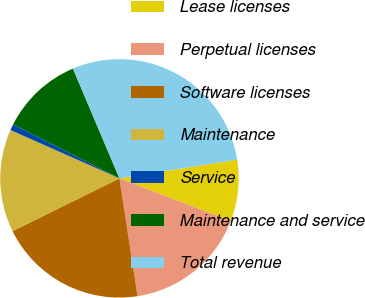<chart> <loc_0><loc_0><loc_500><loc_500><pie_chart><fcel>Lease licenses<fcel>Perpetual licenses<fcel>Software licenses<fcel>Maintenance<fcel>Service<fcel>Maintenance and service<fcel>Total revenue<nl><fcel>8.34%<fcel>16.75%<fcel>20.13%<fcel>13.94%<fcel>0.84%<fcel>11.14%<fcel>28.86%<nl></chart> 